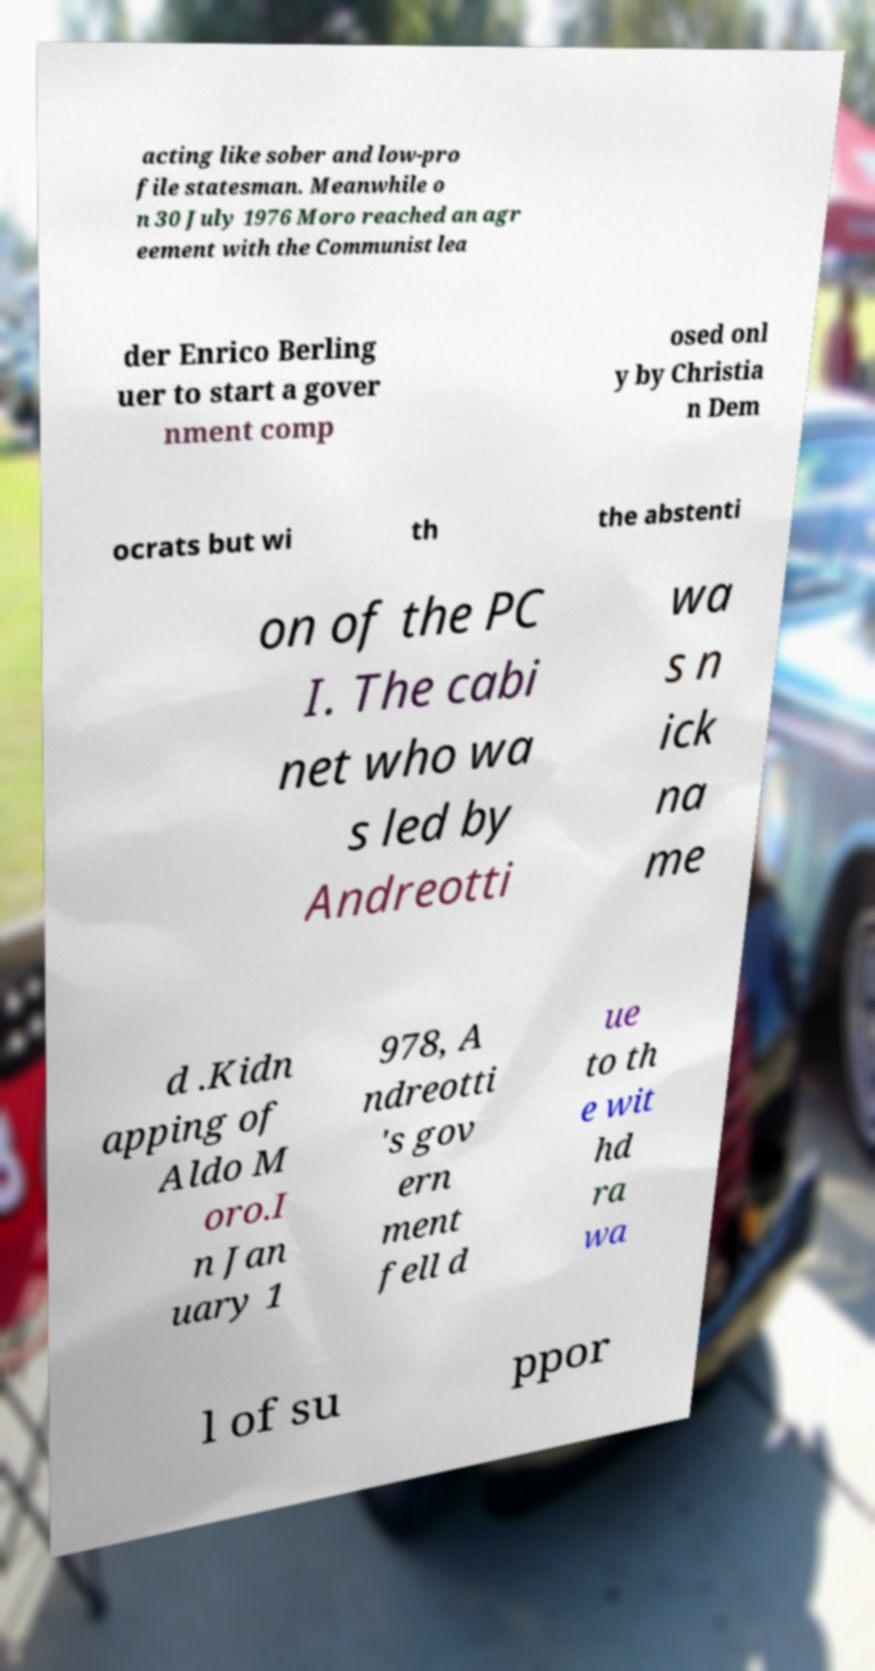I need the written content from this picture converted into text. Can you do that? acting like sober and low-pro file statesman. Meanwhile o n 30 July 1976 Moro reached an agr eement with the Communist lea der Enrico Berling uer to start a gover nment comp osed onl y by Christia n Dem ocrats but wi th the abstenti on of the PC I. The cabi net who wa s led by Andreotti wa s n ick na me d .Kidn apping of Aldo M oro.I n Jan uary 1 978, A ndreotti 's gov ern ment fell d ue to th e wit hd ra wa l of su ppor 